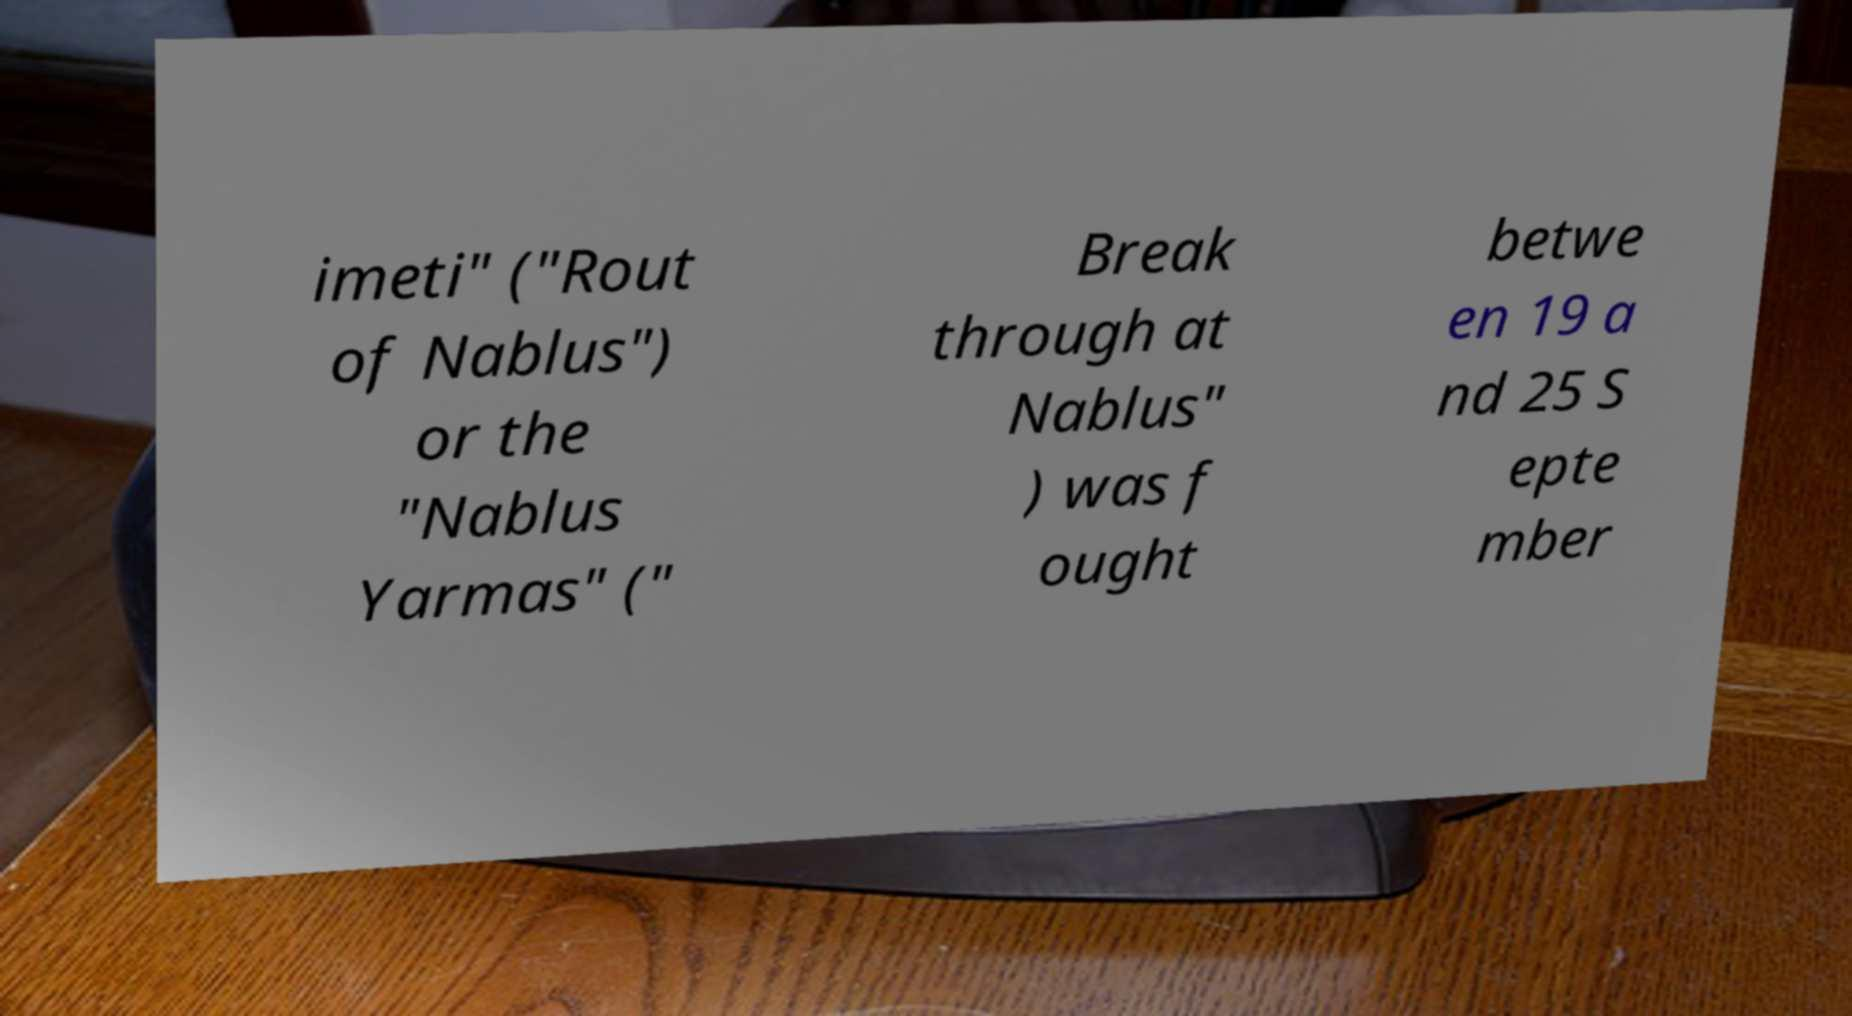Please read and relay the text visible in this image. What does it say? imeti" ("Rout of Nablus") or the "Nablus Yarmas" (" Break through at Nablus" ) was f ought betwe en 19 a nd 25 S epte mber 